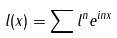<formula> <loc_0><loc_0><loc_500><loc_500>l ( x ) = \sum l ^ { n } e ^ { i n x }</formula> 